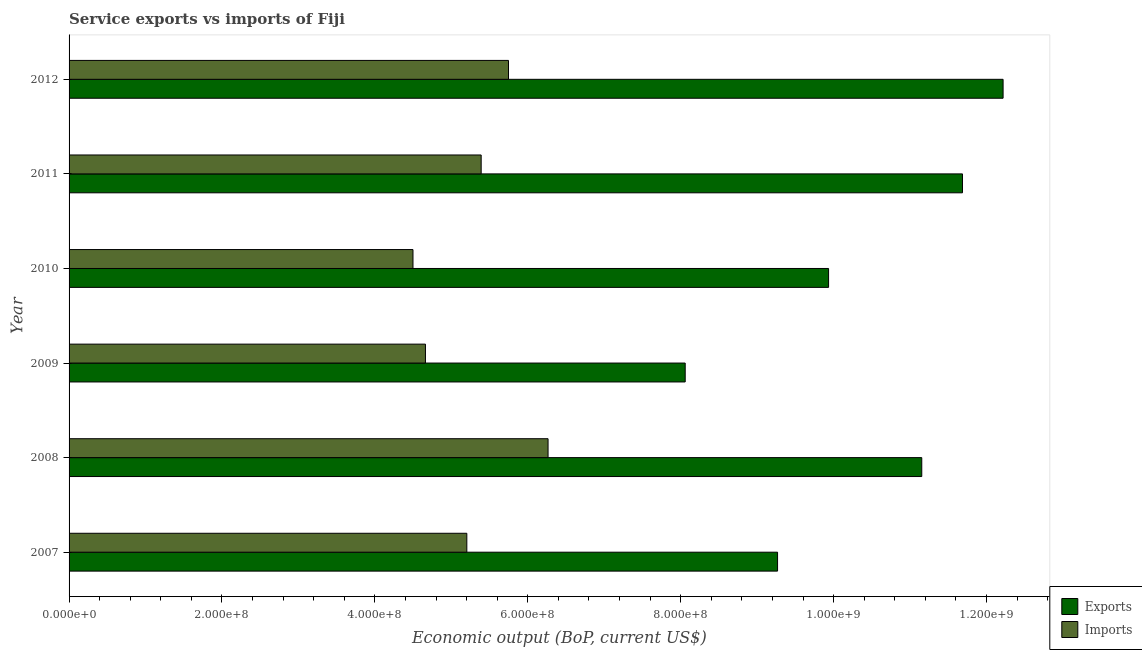Are the number of bars per tick equal to the number of legend labels?
Your answer should be very brief. Yes. Are the number of bars on each tick of the Y-axis equal?
Make the answer very short. Yes. How many bars are there on the 5th tick from the top?
Offer a terse response. 2. What is the amount of service imports in 2010?
Your answer should be very brief. 4.50e+08. Across all years, what is the maximum amount of service imports?
Provide a short and direct response. 6.27e+08. Across all years, what is the minimum amount of service exports?
Your answer should be very brief. 8.06e+08. In which year was the amount of service imports maximum?
Keep it short and to the point. 2008. What is the total amount of service exports in the graph?
Your response must be concise. 6.23e+09. What is the difference between the amount of service imports in 2008 and that in 2011?
Ensure brevity in your answer.  8.75e+07. What is the difference between the amount of service exports in 2011 and the amount of service imports in 2009?
Give a very brief answer. 7.02e+08. What is the average amount of service exports per year?
Your response must be concise. 1.04e+09. In the year 2008, what is the difference between the amount of service exports and amount of service imports?
Provide a short and direct response. 4.89e+08. In how many years, is the amount of service exports greater than 960000000 US$?
Provide a succinct answer. 4. What is the ratio of the amount of service imports in 2008 to that in 2010?
Keep it short and to the point. 1.39. What is the difference between the highest and the second highest amount of service imports?
Your response must be concise. 5.17e+07. What is the difference between the highest and the lowest amount of service exports?
Make the answer very short. 4.16e+08. Is the sum of the amount of service imports in 2008 and 2012 greater than the maximum amount of service exports across all years?
Offer a very short reply. No. What does the 2nd bar from the top in 2007 represents?
Your answer should be very brief. Exports. What does the 1st bar from the bottom in 2009 represents?
Your answer should be very brief. Exports. How many years are there in the graph?
Give a very brief answer. 6. What is the difference between two consecutive major ticks on the X-axis?
Your answer should be very brief. 2.00e+08. Where does the legend appear in the graph?
Give a very brief answer. Bottom right. How are the legend labels stacked?
Your answer should be very brief. Vertical. What is the title of the graph?
Make the answer very short. Service exports vs imports of Fiji. Does "Current US$" appear as one of the legend labels in the graph?
Your answer should be very brief. No. What is the label or title of the X-axis?
Give a very brief answer. Economic output (BoP, current US$). What is the Economic output (BoP, current US$) in Exports in 2007?
Offer a terse response. 9.27e+08. What is the Economic output (BoP, current US$) in Imports in 2007?
Your answer should be very brief. 5.20e+08. What is the Economic output (BoP, current US$) of Exports in 2008?
Offer a terse response. 1.12e+09. What is the Economic output (BoP, current US$) of Imports in 2008?
Provide a succinct answer. 6.27e+08. What is the Economic output (BoP, current US$) of Exports in 2009?
Offer a terse response. 8.06e+08. What is the Economic output (BoP, current US$) in Imports in 2009?
Give a very brief answer. 4.66e+08. What is the Economic output (BoP, current US$) of Exports in 2010?
Give a very brief answer. 9.93e+08. What is the Economic output (BoP, current US$) in Imports in 2010?
Keep it short and to the point. 4.50e+08. What is the Economic output (BoP, current US$) of Exports in 2011?
Ensure brevity in your answer.  1.17e+09. What is the Economic output (BoP, current US$) of Imports in 2011?
Provide a short and direct response. 5.39e+08. What is the Economic output (BoP, current US$) of Exports in 2012?
Offer a terse response. 1.22e+09. What is the Economic output (BoP, current US$) of Imports in 2012?
Your answer should be very brief. 5.75e+08. Across all years, what is the maximum Economic output (BoP, current US$) of Exports?
Ensure brevity in your answer.  1.22e+09. Across all years, what is the maximum Economic output (BoP, current US$) in Imports?
Make the answer very short. 6.27e+08. Across all years, what is the minimum Economic output (BoP, current US$) in Exports?
Your answer should be very brief. 8.06e+08. Across all years, what is the minimum Economic output (BoP, current US$) of Imports?
Offer a very short reply. 4.50e+08. What is the total Economic output (BoP, current US$) in Exports in the graph?
Provide a short and direct response. 6.23e+09. What is the total Economic output (BoP, current US$) of Imports in the graph?
Your answer should be compact. 3.18e+09. What is the difference between the Economic output (BoP, current US$) in Exports in 2007 and that in 2008?
Offer a terse response. -1.89e+08. What is the difference between the Economic output (BoP, current US$) of Imports in 2007 and that in 2008?
Offer a very short reply. -1.06e+08. What is the difference between the Economic output (BoP, current US$) of Exports in 2007 and that in 2009?
Provide a short and direct response. 1.21e+08. What is the difference between the Economic output (BoP, current US$) in Imports in 2007 and that in 2009?
Your answer should be very brief. 5.41e+07. What is the difference between the Economic output (BoP, current US$) in Exports in 2007 and that in 2010?
Provide a short and direct response. -6.67e+07. What is the difference between the Economic output (BoP, current US$) in Imports in 2007 and that in 2010?
Provide a short and direct response. 7.04e+07. What is the difference between the Economic output (BoP, current US$) of Exports in 2007 and that in 2011?
Offer a terse response. -2.42e+08. What is the difference between the Economic output (BoP, current US$) in Imports in 2007 and that in 2011?
Offer a very short reply. -1.88e+07. What is the difference between the Economic output (BoP, current US$) in Exports in 2007 and that in 2012?
Ensure brevity in your answer.  -2.95e+08. What is the difference between the Economic output (BoP, current US$) of Imports in 2007 and that in 2012?
Ensure brevity in your answer.  -5.45e+07. What is the difference between the Economic output (BoP, current US$) in Exports in 2008 and that in 2009?
Offer a terse response. 3.09e+08. What is the difference between the Economic output (BoP, current US$) of Imports in 2008 and that in 2009?
Your response must be concise. 1.60e+08. What is the difference between the Economic output (BoP, current US$) in Exports in 2008 and that in 2010?
Your answer should be very brief. 1.22e+08. What is the difference between the Economic output (BoP, current US$) of Imports in 2008 and that in 2010?
Provide a succinct answer. 1.77e+08. What is the difference between the Economic output (BoP, current US$) in Exports in 2008 and that in 2011?
Keep it short and to the point. -5.33e+07. What is the difference between the Economic output (BoP, current US$) in Imports in 2008 and that in 2011?
Keep it short and to the point. 8.75e+07. What is the difference between the Economic output (BoP, current US$) in Exports in 2008 and that in 2012?
Your response must be concise. -1.06e+08. What is the difference between the Economic output (BoP, current US$) in Imports in 2008 and that in 2012?
Your answer should be compact. 5.17e+07. What is the difference between the Economic output (BoP, current US$) in Exports in 2009 and that in 2010?
Ensure brevity in your answer.  -1.88e+08. What is the difference between the Economic output (BoP, current US$) of Imports in 2009 and that in 2010?
Give a very brief answer. 1.63e+07. What is the difference between the Economic output (BoP, current US$) of Exports in 2009 and that in 2011?
Make the answer very short. -3.63e+08. What is the difference between the Economic output (BoP, current US$) in Imports in 2009 and that in 2011?
Make the answer very short. -7.29e+07. What is the difference between the Economic output (BoP, current US$) of Exports in 2009 and that in 2012?
Provide a short and direct response. -4.16e+08. What is the difference between the Economic output (BoP, current US$) in Imports in 2009 and that in 2012?
Your answer should be compact. -1.09e+08. What is the difference between the Economic output (BoP, current US$) of Exports in 2010 and that in 2011?
Make the answer very short. -1.75e+08. What is the difference between the Economic output (BoP, current US$) in Imports in 2010 and that in 2011?
Offer a terse response. -8.92e+07. What is the difference between the Economic output (BoP, current US$) in Exports in 2010 and that in 2012?
Provide a short and direct response. -2.28e+08. What is the difference between the Economic output (BoP, current US$) in Imports in 2010 and that in 2012?
Provide a succinct answer. -1.25e+08. What is the difference between the Economic output (BoP, current US$) of Exports in 2011 and that in 2012?
Offer a terse response. -5.31e+07. What is the difference between the Economic output (BoP, current US$) of Imports in 2011 and that in 2012?
Ensure brevity in your answer.  -3.57e+07. What is the difference between the Economic output (BoP, current US$) of Exports in 2007 and the Economic output (BoP, current US$) of Imports in 2008?
Ensure brevity in your answer.  3.00e+08. What is the difference between the Economic output (BoP, current US$) in Exports in 2007 and the Economic output (BoP, current US$) in Imports in 2009?
Ensure brevity in your answer.  4.61e+08. What is the difference between the Economic output (BoP, current US$) in Exports in 2007 and the Economic output (BoP, current US$) in Imports in 2010?
Provide a short and direct response. 4.77e+08. What is the difference between the Economic output (BoP, current US$) of Exports in 2007 and the Economic output (BoP, current US$) of Imports in 2011?
Your answer should be very brief. 3.88e+08. What is the difference between the Economic output (BoP, current US$) in Exports in 2007 and the Economic output (BoP, current US$) in Imports in 2012?
Make the answer very short. 3.52e+08. What is the difference between the Economic output (BoP, current US$) of Exports in 2008 and the Economic output (BoP, current US$) of Imports in 2009?
Keep it short and to the point. 6.49e+08. What is the difference between the Economic output (BoP, current US$) in Exports in 2008 and the Economic output (BoP, current US$) in Imports in 2010?
Provide a short and direct response. 6.65e+08. What is the difference between the Economic output (BoP, current US$) in Exports in 2008 and the Economic output (BoP, current US$) in Imports in 2011?
Ensure brevity in your answer.  5.76e+08. What is the difference between the Economic output (BoP, current US$) of Exports in 2008 and the Economic output (BoP, current US$) of Imports in 2012?
Offer a very short reply. 5.41e+08. What is the difference between the Economic output (BoP, current US$) in Exports in 2009 and the Economic output (BoP, current US$) in Imports in 2010?
Provide a short and direct response. 3.56e+08. What is the difference between the Economic output (BoP, current US$) of Exports in 2009 and the Economic output (BoP, current US$) of Imports in 2011?
Ensure brevity in your answer.  2.67e+08. What is the difference between the Economic output (BoP, current US$) of Exports in 2009 and the Economic output (BoP, current US$) of Imports in 2012?
Your answer should be very brief. 2.31e+08. What is the difference between the Economic output (BoP, current US$) of Exports in 2010 and the Economic output (BoP, current US$) of Imports in 2011?
Your response must be concise. 4.54e+08. What is the difference between the Economic output (BoP, current US$) of Exports in 2010 and the Economic output (BoP, current US$) of Imports in 2012?
Your answer should be very brief. 4.19e+08. What is the difference between the Economic output (BoP, current US$) of Exports in 2011 and the Economic output (BoP, current US$) of Imports in 2012?
Make the answer very short. 5.94e+08. What is the average Economic output (BoP, current US$) in Exports per year?
Keep it short and to the point. 1.04e+09. What is the average Economic output (BoP, current US$) of Imports per year?
Ensure brevity in your answer.  5.29e+08. In the year 2007, what is the difference between the Economic output (BoP, current US$) of Exports and Economic output (BoP, current US$) of Imports?
Offer a terse response. 4.06e+08. In the year 2008, what is the difference between the Economic output (BoP, current US$) in Exports and Economic output (BoP, current US$) in Imports?
Your answer should be very brief. 4.89e+08. In the year 2009, what is the difference between the Economic output (BoP, current US$) of Exports and Economic output (BoP, current US$) of Imports?
Give a very brief answer. 3.40e+08. In the year 2010, what is the difference between the Economic output (BoP, current US$) of Exports and Economic output (BoP, current US$) of Imports?
Provide a succinct answer. 5.44e+08. In the year 2011, what is the difference between the Economic output (BoP, current US$) of Exports and Economic output (BoP, current US$) of Imports?
Your response must be concise. 6.30e+08. In the year 2012, what is the difference between the Economic output (BoP, current US$) in Exports and Economic output (BoP, current US$) in Imports?
Offer a very short reply. 6.47e+08. What is the ratio of the Economic output (BoP, current US$) of Exports in 2007 to that in 2008?
Your response must be concise. 0.83. What is the ratio of the Economic output (BoP, current US$) in Imports in 2007 to that in 2008?
Keep it short and to the point. 0.83. What is the ratio of the Economic output (BoP, current US$) of Exports in 2007 to that in 2009?
Your answer should be compact. 1.15. What is the ratio of the Economic output (BoP, current US$) in Imports in 2007 to that in 2009?
Ensure brevity in your answer.  1.12. What is the ratio of the Economic output (BoP, current US$) in Exports in 2007 to that in 2010?
Your response must be concise. 0.93. What is the ratio of the Economic output (BoP, current US$) of Imports in 2007 to that in 2010?
Provide a succinct answer. 1.16. What is the ratio of the Economic output (BoP, current US$) in Exports in 2007 to that in 2011?
Provide a short and direct response. 0.79. What is the ratio of the Economic output (BoP, current US$) of Imports in 2007 to that in 2011?
Your answer should be very brief. 0.97. What is the ratio of the Economic output (BoP, current US$) in Exports in 2007 to that in 2012?
Your response must be concise. 0.76. What is the ratio of the Economic output (BoP, current US$) of Imports in 2007 to that in 2012?
Provide a short and direct response. 0.91. What is the ratio of the Economic output (BoP, current US$) of Exports in 2008 to that in 2009?
Give a very brief answer. 1.38. What is the ratio of the Economic output (BoP, current US$) of Imports in 2008 to that in 2009?
Your answer should be very brief. 1.34. What is the ratio of the Economic output (BoP, current US$) of Exports in 2008 to that in 2010?
Offer a terse response. 1.12. What is the ratio of the Economic output (BoP, current US$) in Imports in 2008 to that in 2010?
Provide a succinct answer. 1.39. What is the ratio of the Economic output (BoP, current US$) in Exports in 2008 to that in 2011?
Offer a very short reply. 0.95. What is the ratio of the Economic output (BoP, current US$) of Imports in 2008 to that in 2011?
Make the answer very short. 1.16. What is the ratio of the Economic output (BoP, current US$) in Exports in 2008 to that in 2012?
Your response must be concise. 0.91. What is the ratio of the Economic output (BoP, current US$) in Imports in 2008 to that in 2012?
Your answer should be very brief. 1.09. What is the ratio of the Economic output (BoP, current US$) in Exports in 2009 to that in 2010?
Provide a short and direct response. 0.81. What is the ratio of the Economic output (BoP, current US$) of Imports in 2009 to that in 2010?
Provide a short and direct response. 1.04. What is the ratio of the Economic output (BoP, current US$) in Exports in 2009 to that in 2011?
Provide a succinct answer. 0.69. What is the ratio of the Economic output (BoP, current US$) in Imports in 2009 to that in 2011?
Ensure brevity in your answer.  0.86. What is the ratio of the Economic output (BoP, current US$) of Exports in 2009 to that in 2012?
Make the answer very short. 0.66. What is the ratio of the Economic output (BoP, current US$) of Imports in 2009 to that in 2012?
Your answer should be compact. 0.81. What is the ratio of the Economic output (BoP, current US$) of Exports in 2010 to that in 2011?
Keep it short and to the point. 0.85. What is the ratio of the Economic output (BoP, current US$) of Imports in 2010 to that in 2011?
Provide a succinct answer. 0.83. What is the ratio of the Economic output (BoP, current US$) of Exports in 2010 to that in 2012?
Give a very brief answer. 0.81. What is the ratio of the Economic output (BoP, current US$) in Imports in 2010 to that in 2012?
Your answer should be very brief. 0.78. What is the ratio of the Economic output (BoP, current US$) of Exports in 2011 to that in 2012?
Keep it short and to the point. 0.96. What is the ratio of the Economic output (BoP, current US$) in Imports in 2011 to that in 2012?
Offer a very short reply. 0.94. What is the difference between the highest and the second highest Economic output (BoP, current US$) of Exports?
Your answer should be very brief. 5.31e+07. What is the difference between the highest and the second highest Economic output (BoP, current US$) in Imports?
Your answer should be very brief. 5.17e+07. What is the difference between the highest and the lowest Economic output (BoP, current US$) of Exports?
Keep it short and to the point. 4.16e+08. What is the difference between the highest and the lowest Economic output (BoP, current US$) of Imports?
Your answer should be very brief. 1.77e+08. 